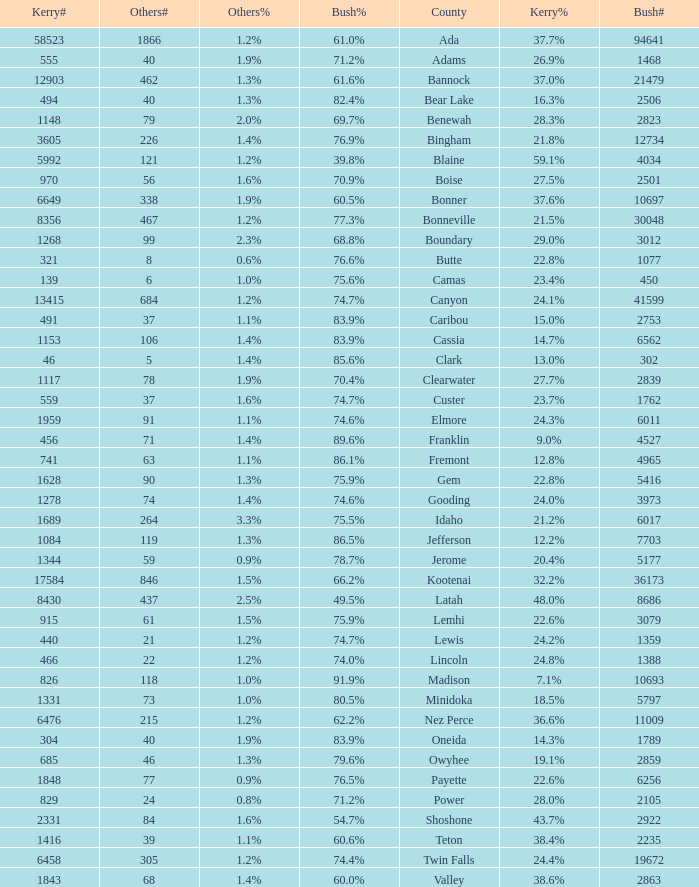What percentage of the people in Bonneville voted for Bush? 77.3%. 